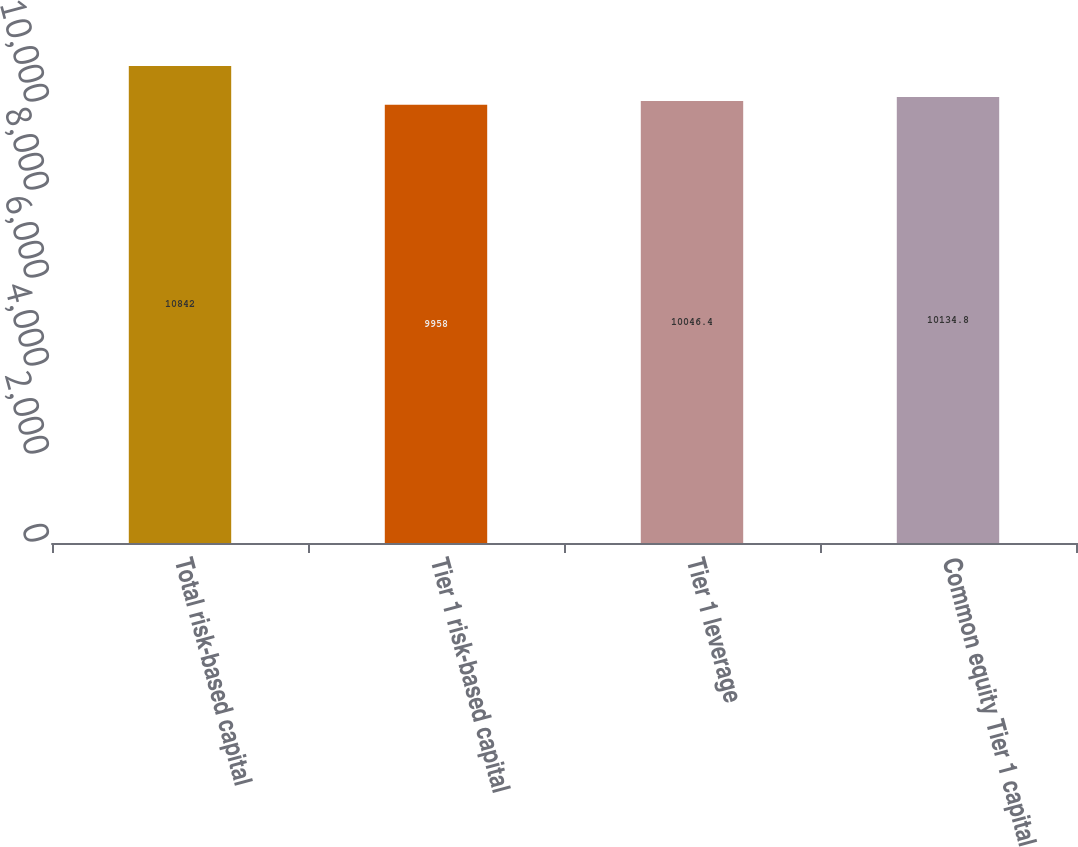Convert chart. <chart><loc_0><loc_0><loc_500><loc_500><bar_chart><fcel>Total risk-based capital<fcel>Tier 1 risk-based capital<fcel>Tier 1 leverage<fcel>Common equity Tier 1 capital<nl><fcel>10842<fcel>9958<fcel>10046.4<fcel>10134.8<nl></chart> 